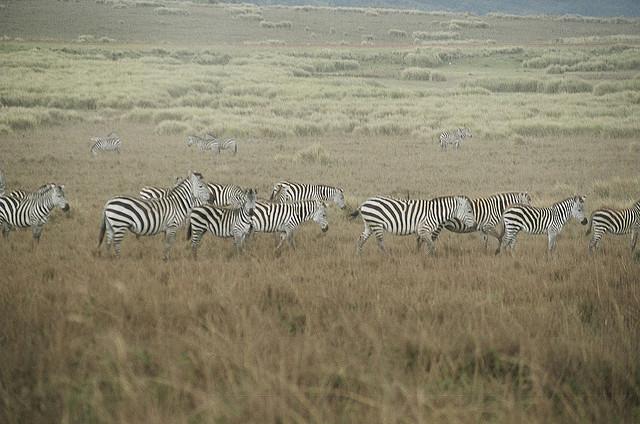Are the zebras related?
Give a very brief answer. Yes. What type of animals are shown?
Be succinct. Zebras. Where are the animals?
Keep it brief. Zebras. Is there a cactus in the picture?
Give a very brief answer. No. 